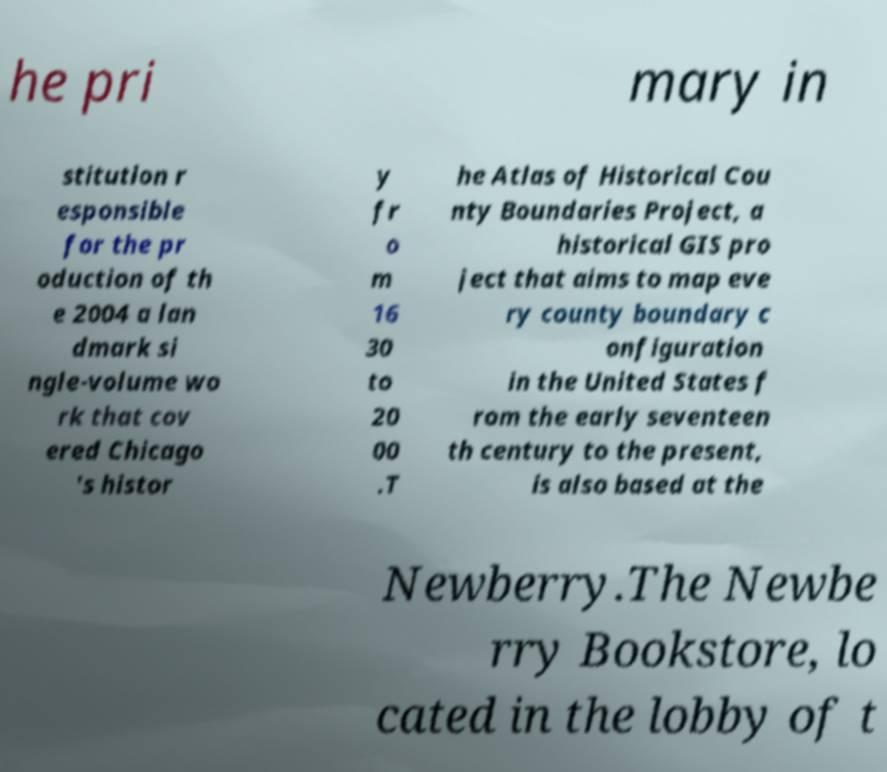Can you accurately transcribe the text from the provided image for me? he pri mary in stitution r esponsible for the pr oduction of th e 2004 a lan dmark si ngle-volume wo rk that cov ered Chicago 's histor y fr o m 16 30 to 20 00 .T he Atlas of Historical Cou nty Boundaries Project, a historical GIS pro ject that aims to map eve ry county boundary c onfiguration in the United States f rom the early seventeen th century to the present, is also based at the Newberry.The Newbe rry Bookstore, lo cated in the lobby of t 